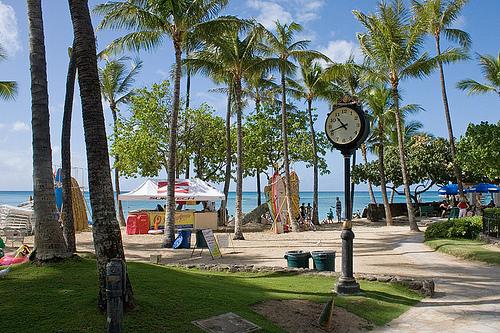Which is ocean is likely shown here?
Quick response, please. Pacific. What time is on the clock?
Write a very short answer. 10:42. Where is a clock?
Be succinct. On pole. 